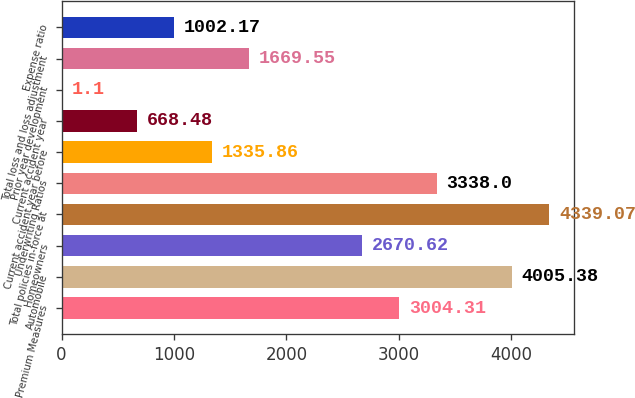Convert chart to OTSL. <chart><loc_0><loc_0><loc_500><loc_500><bar_chart><fcel>Premium Measures<fcel>Automobile<fcel>Homeowners<fcel>Total policies in-force at<fcel>Underwriting Ratios<fcel>Current accident year before<fcel>Current accident year<fcel>Prior year development<fcel>Total loss and loss adjustment<fcel>Expense ratio<nl><fcel>3004.31<fcel>4005.38<fcel>2670.62<fcel>4339.07<fcel>3338<fcel>1335.86<fcel>668.48<fcel>1.1<fcel>1669.55<fcel>1002.17<nl></chart> 